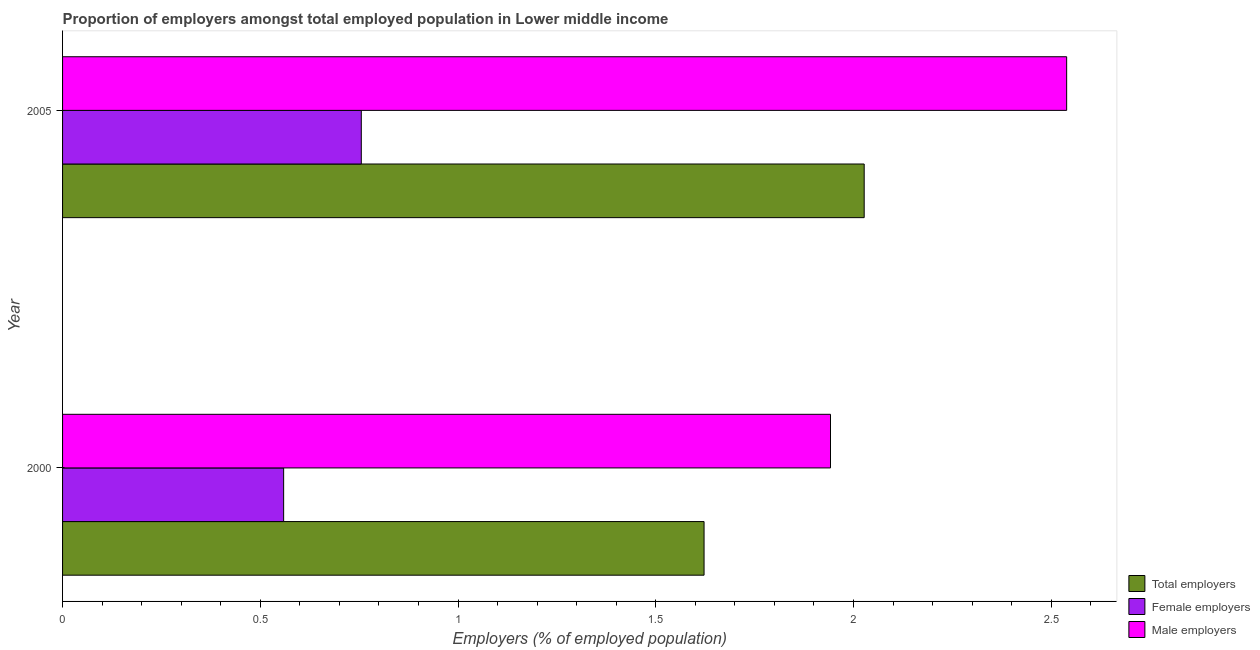How many different coloured bars are there?
Keep it short and to the point. 3. Are the number of bars on each tick of the Y-axis equal?
Offer a very short reply. Yes. How many bars are there on the 1st tick from the top?
Your answer should be very brief. 3. What is the percentage of total employers in 2000?
Keep it short and to the point. 1.62. Across all years, what is the maximum percentage of total employers?
Offer a very short reply. 2.03. Across all years, what is the minimum percentage of male employers?
Keep it short and to the point. 1.94. In which year was the percentage of total employers maximum?
Provide a succinct answer. 2005. What is the total percentage of total employers in the graph?
Your answer should be compact. 3.65. What is the difference between the percentage of total employers in 2000 and that in 2005?
Offer a very short reply. -0.41. What is the difference between the percentage of female employers in 2000 and the percentage of male employers in 2005?
Offer a terse response. -1.98. What is the average percentage of female employers per year?
Give a very brief answer. 0.66. In the year 2005, what is the difference between the percentage of total employers and percentage of male employers?
Make the answer very short. -0.51. In how many years, is the percentage of male employers greater than 1.1 %?
Make the answer very short. 2. What is the ratio of the percentage of male employers in 2000 to that in 2005?
Ensure brevity in your answer.  0.77. Is the percentage of male employers in 2000 less than that in 2005?
Give a very brief answer. Yes. Is the difference between the percentage of total employers in 2000 and 2005 greater than the difference between the percentage of male employers in 2000 and 2005?
Provide a succinct answer. Yes. What does the 3rd bar from the top in 2005 represents?
Make the answer very short. Total employers. What does the 1st bar from the bottom in 2005 represents?
Your response must be concise. Total employers. How many bars are there?
Offer a terse response. 6. Does the graph contain grids?
Your answer should be compact. No. How are the legend labels stacked?
Your answer should be very brief. Vertical. What is the title of the graph?
Offer a very short reply. Proportion of employers amongst total employed population in Lower middle income. Does "Industrial Nitrous Oxide" appear as one of the legend labels in the graph?
Offer a very short reply. No. What is the label or title of the X-axis?
Offer a very short reply. Employers (% of employed population). What is the Employers (% of employed population) of Total employers in 2000?
Provide a succinct answer. 1.62. What is the Employers (% of employed population) in Female employers in 2000?
Provide a succinct answer. 0.56. What is the Employers (% of employed population) of Male employers in 2000?
Give a very brief answer. 1.94. What is the Employers (% of employed population) of Total employers in 2005?
Your response must be concise. 2.03. What is the Employers (% of employed population) in Female employers in 2005?
Your response must be concise. 0.76. What is the Employers (% of employed population) of Male employers in 2005?
Give a very brief answer. 2.54. Across all years, what is the maximum Employers (% of employed population) in Total employers?
Keep it short and to the point. 2.03. Across all years, what is the maximum Employers (% of employed population) of Female employers?
Provide a short and direct response. 0.76. Across all years, what is the maximum Employers (% of employed population) in Male employers?
Provide a short and direct response. 2.54. Across all years, what is the minimum Employers (% of employed population) in Total employers?
Make the answer very short. 1.62. Across all years, what is the minimum Employers (% of employed population) in Female employers?
Give a very brief answer. 0.56. Across all years, what is the minimum Employers (% of employed population) of Male employers?
Make the answer very short. 1.94. What is the total Employers (% of employed population) of Total employers in the graph?
Give a very brief answer. 3.65. What is the total Employers (% of employed population) of Female employers in the graph?
Your answer should be very brief. 1.31. What is the total Employers (% of employed population) in Male employers in the graph?
Your answer should be compact. 4.48. What is the difference between the Employers (% of employed population) of Total employers in 2000 and that in 2005?
Your answer should be very brief. -0.4. What is the difference between the Employers (% of employed population) in Female employers in 2000 and that in 2005?
Your response must be concise. -0.2. What is the difference between the Employers (% of employed population) of Male employers in 2000 and that in 2005?
Provide a succinct answer. -0.6. What is the difference between the Employers (% of employed population) of Total employers in 2000 and the Employers (% of employed population) of Female employers in 2005?
Your response must be concise. 0.87. What is the difference between the Employers (% of employed population) of Total employers in 2000 and the Employers (% of employed population) of Male employers in 2005?
Keep it short and to the point. -0.92. What is the difference between the Employers (% of employed population) of Female employers in 2000 and the Employers (% of employed population) of Male employers in 2005?
Offer a very short reply. -1.98. What is the average Employers (% of employed population) in Total employers per year?
Your response must be concise. 1.82. What is the average Employers (% of employed population) of Female employers per year?
Offer a terse response. 0.66. What is the average Employers (% of employed population) of Male employers per year?
Provide a succinct answer. 2.24. In the year 2000, what is the difference between the Employers (% of employed population) in Total employers and Employers (% of employed population) in Female employers?
Your answer should be compact. 1.06. In the year 2000, what is the difference between the Employers (% of employed population) of Total employers and Employers (% of employed population) of Male employers?
Provide a succinct answer. -0.32. In the year 2000, what is the difference between the Employers (% of employed population) of Female employers and Employers (% of employed population) of Male employers?
Offer a very short reply. -1.38. In the year 2005, what is the difference between the Employers (% of employed population) in Total employers and Employers (% of employed population) in Female employers?
Ensure brevity in your answer.  1.27. In the year 2005, what is the difference between the Employers (% of employed population) in Total employers and Employers (% of employed population) in Male employers?
Offer a terse response. -0.51. In the year 2005, what is the difference between the Employers (% of employed population) of Female employers and Employers (% of employed population) of Male employers?
Provide a succinct answer. -1.78. What is the ratio of the Employers (% of employed population) in Total employers in 2000 to that in 2005?
Offer a very short reply. 0.8. What is the ratio of the Employers (% of employed population) in Female employers in 2000 to that in 2005?
Make the answer very short. 0.74. What is the ratio of the Employers (% of employed population) in Male employers in 2000 to that in 2005?
Provide a succinct answer. 0.76. What is the difference between the highest and the second highest Employers (% of employed population) in Total employers?
Your response must be concise. 0.4. What is the difference between the highest and the second highest Employers (% of employed population) of Female employers?
Ensure brevity in your answer.  0.2. What is the difference between the highest and the second highest Employers (% of employed population) of Male employers?
Keep it short and to the point. 0.6. What is the difference between the highest and the lowest Employers (% of employed population) in Total employers?
Give a very brief answer. 0.4. What is the difference between the highest and the lowest Employers (% of employed population) of Female employers?
Provide a succinct answer. 0.2. What is the difference between the highest and the lowest Employers (% of employed population) of Male employers?
Offer a terse response. 0.6. 